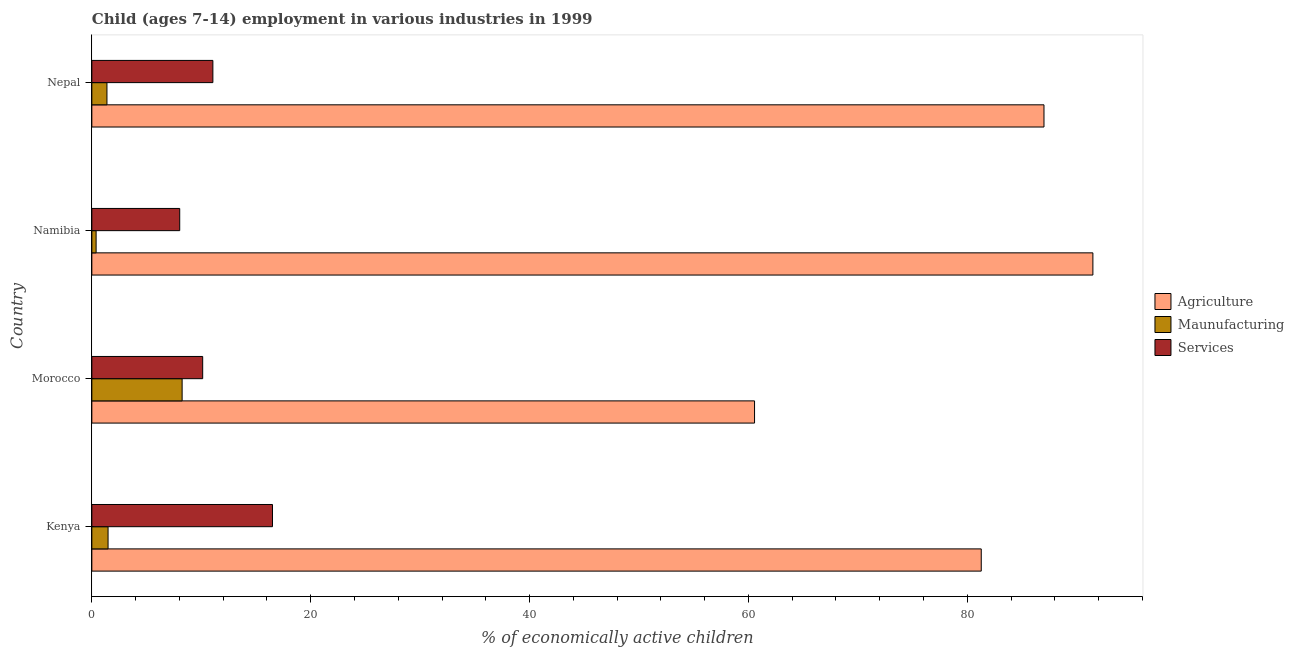How many different coloured bars are there?
Your answer should be compact. 3. How many groups of bars are there?
Ensure brevity in your answer.  4. How many bars are there on the 3rd tick from the bottom?
Offer a very short reply. 3. What is the label of the 1st group of bars from the top?
Provide a succinct answer. Nepal. In how many cases, is the number of bars for a given country not equal to the number of legend labels?
Keep it short and to the point. 0. What is the percentage of economically active children in services in Nepal?
Ensure brevity in your answer.  11.06. Across all countries, what is the maximum percentage of economically active children in services?
Give a very brief answer. 16.51. Across all countries, what is the minimum percentage of economically active children in services?
Ensure brevity in your answer.  8.03. In which country was the percentage of economically active children in agriculture maximum?
Give a very brief answer. Namibia. In which country was the percentage of economically active children in services minimum?
Make the answer very short. Namibia. What is the total percentage of economically active children in agriculture in the graph?
Provide a short and direct response. 320.33. What is the difference between the percentage of economically active children in services in Kenya and that in Nepal?
Provide a succinct answer. 5.45. What is the difference between the percentage of economically active children in services in Kenya and the percentage of economically active children in agriculture in Nepal?
Give a very brief answer. -70.5. What is the average percentage of economically active children in manufacturing per country?
Provide a short and direct response. 2.88. What is the difference between the percentage of economically active children in services and percentage of economically active children in manufacturing in Nepal?
Your answer should be very brief. 9.68. What is the ratio of the percentage of economically active children in services in Morocco to that in Namibia?
Give a very brief answer. 1.26. Is the difference between the percentage of economically active children in agriculture in Namibia and Nepal greater than the difference between the percentage of economically active children in services in Namibia and Nepal?
Ensure brevity in your answer.  Yes. What is the difference between the highest and the second highest percentage of economically active children in services?
Make the answer very short. 5.45. What is the difference between the highest and the lowest percentage of economically active children in agriculture?
Your response must be concise. 30.92. In how many countries, is the percentage of economically active children in services greater than the average percentage of economically active children in services taken over all countries?
Offer a very short reply. 1. Is the sum of the percentage of economically active children in manufacturing in Kenya and Namibia greater than the maximum percentage of economically active children in agriculture across all countries?
Your response must be concise. No. What does the 3rd bar from the top in Namibia represents?
Offer a terse response. Agriculture. What does the 2nd bar from the bottom in Kenya represents?
Offer a terse response. Maunufacturing. Is it the case that in every country, the sum of the percentage of economically active children in agriculture and percentage of economically active children in manufacturing is greater than the percentage of economically active children in services?
Make the answer very short. Yes. How many bars are there?
Offer a terse response. 12. How many countries are there in the graph?
Your answer should be compact. 4. Are the values on the major ticks of X-axis written in scientific E-notation?
Offer a terse response. No. Does the graph contain grids?
Offer a terse response. No. Where does the legend appear in the graph?
Your response must be concise. Center right. What is the title of the graph?
Offer a terse response. Child (ages 7-14) employment in various industries in 1999. Does "Financial account" appear as one of the legend labels in the graph?
Keep it short and to the point. No. What is the label or title of the X-axis?
Keep it short and to the point. % of economically active children. What is the label or title of the Y-axis?
Provide a succinct answer. Country. What is the % of economically active children of Agriculture in Kenya?
Provide a succinct answer. 81.28. What is the % of economically active children in Maunufacturing in Kenya?
Your response must be concise. 1.48. What is the % of economically active children of Services in Kenya?
Give a very brief answer. 16.51. What is the % of economically active children in Agriculture in Morocco?
Provide a short and direct response. 60.56. What is the % of economically active children in Maunufacturing in Morocco?
Offer a terse response. 8.25. What is the % of economically active children in Services in Morocco?
Keep it short and to the point. 10.13. What is the % of economically active children of Agriculture in Namibia?
Give a very brief answer. 91.48. What is the % of economically active children in Maunufacturing in Namibia?
Ensure brevity in your answer.  0.39. What is the % of economically active children in Services in Namibia?
Provide a short and direct response. 8.03. What is the % of economically active children in Agriculture in Nepal?
Provide a succinct answer. 87.01. What is the % of economically active children of Maunufacturing in Nepal?
Your response must be concise. 1.38. What is the % of economically active children of Services in Nepal?
Offer a terse response. 11.06. Across all countries, what is the maximum % of economically active children in Agriculture?
Keep it short and to the point. 91.48. Across all countries, what is the maximum % of economically active children of Maunufacturing?
Ensure brevity in your answer.  8.25. Across all countries, what is the maximum % of economically active children in Services?
Your answer should be compact. 16.51. Across all countries, what is the minimum % of economically active children in Agriculture?
Give a very brief answer. 60.56. Across all countries, what is the minimum % of economically active children in Maunufacturing?
Keep it short and to the point. 0.39. Across all countries, what is the minimum % of economically active children of Services?
Your answer should be compact. 8.03. What is the total % of economically active children of Agriculture in the graph?
Your answer should be very brief. 320.33. What is the total % of economically active children in Maunufacturing in the graph?
Provide a short and direct response. 11.5. What is the total % of economically active children of Services in the graph?
Give a very brief answer. 45.73. What is the difference between the % of economically active children of Agriculture in Kenya and that in Morocco?
Provide a short and direct response. 20.72. What is the difference between the % of economically active children of Maunufacturing in Kenya and that in Morocco?
Your answer should be very brief. -6.77. What is the difference between the % of economically active children in Services in Kenya and that in Morocco?
Give a very brief answer. 6.38. What is the difference between the % of economically active children in Agriculture in Kenya and that in Namibia?
Offer a very short reply. -10.2. What is the difference between the % of economically active children in Maunufacturing in Kenya and that in Namibia?
Offer a very short reply. 1.09. What is the difference between the % of economically active children of Services in Kenya and that in Namibia?
Make the answer very short. 8.48. What is the difference between the % of economically active children in Agriculture in Kenya and that in Nepal?
Your answer should be very brief. -5.73. What is the difference between the % of economically active children in Maunufacturing in Kenya and that in Nepal?
Your answer should be very brief. 0.1. What is the difference between the % of economically active children of Services in Kenya and that in Nepal?
Your response must be concise. 5.45. What is the difference between the % of economically active children in Agriculture in Morocco and that in Namibia?
Offer a terse response. -30.92. What is the difference between the % of economically active children in Maunufacturing in Morocco and that in Namibia?
Offer a terse response. 7.86. What is the difference between the % of economically active children of Services in Morocco and that in Namibia?
Your answer should be compact. 2.1. What is the difference between the % of economically active children in Agriculture in Morocco and that in Nepal?
Offer a terse response. -26.45. What is the difference between the % of economically active children in Maunufacturing in Morocco and that in Nepal?
Ensure brevity in your answer.  6.87. What is the difference between the % of economically active children of Services in Morocco and that in Nepal?
Offer a very short reply. -0.93. What is the difference between the % of economically active children of Agriculture in Namibia and that in Nepal?
Your response must be concise. 4.47. What is the difference between the % of economically active children in Maunufacturing in Namibia and that in Nepal?
Your response must be concise. -0.99. What is the difference between the % of economically active children of Services in Namibia and that in Nepal?
Give a very brief answer. -3.03. What is the difference between the % of economically active children of Agriculture in Kenya and the % of economically active children of Maunufacturing in Morocco?
Your response must be concise. 73.03. What is the difference between the % of economically active children of Agriculture in Kenya and the % of economically active children of Services in Morocco?
Your answer should be very brief. 71.15. What is the difference between the % of economically active children in Maunufacturing in Kenya and the % of economically active children in Services in Morocco?
Offer a terse response. -8.65. What is the difference between the % of economically active children of Agriculture in Kenya and the % of economically active children of Maunufacturing in Namibia?
Give a very brief answer. 80.89. What is the difference between the % of economically active children of Agriculture in Kenya and the % of economically active children of Services in Namibia?
Your answer should be very brief. 73.25. What is the difference between the % of economically active children in Maunufacturing in Kenya and the % of economically active children in Services in Namibia?
Keep it short and to the point. -6.55. What is the difference between the % of economically active children of Agriculture in Kenya and the % of economically active children of Maunufacturing in Nepal?
Make the answer very short. 79.9. What is the difference between the % of economically active children in Agriculture in Kenya and the % of economically active children in Services in Nepal?
Make the answer very short. 70.22. What is the difference between the % of economically active children in Maunufacturing in Kenya and the % of economically active children in Services in Nepal?
Ensure brevity in your answer.  -9.58. What is the difference between the % of economically active children in Agriculture in Morocco and the % of economically active children in Maunufacturing in Namibia?
Offer a very short reply. 60.17. What is the difference between the % of economically active children in Agriculture in Morocco and the % of economically active children in Services in Namibia?
Your response must be concise. 52.53. What is the difference between the % of economically active children of Maunufacturing in Morocco and the % of economically active children of Services in Namibia?
Offer a terse response. 0.22. What is the difference between the % of economically active children in Agriculture in Morocco and the % of economically active children in Maunufacturing in Nepal?
Your response must be concise. 59.18. What is the difference between the % of economically active children in Agriculture in Morocco and the % of economically active children in Services in Nepal?
Offer a very short reply. 49.5. What is the difference between the % of economically active children in Maunufacturing in Morocco and the % of economically active children in Services in Nepal?
Your response must be concise. -2.81. What is the difference between the % of economically active children of Agriculture in Namibia and the % of economically active children of Maunufacturing in Nepal?
Make the answer very short. 90.1. What is the difference between the % of economically active children of Agriculture in Namibia and the % of economically active children of Services in Nepal?
Provide a succinct answer. 80.42. What is the difference between the % of economically active children in Maunufacturing in Namibia and the % of economically active children in Services in Nepal?
Make the answer very short. -10.67. What is the average % of economically active children in Agriculture per country?
Provide a succinct answer. 80.08. What is the average % of economically active children in Maunufacturing per country?
Make the answer very short. 2.88. What is the average % of economically active children in Services per country?
Your answer should be very brief. 11.43. What is the difference between the % of economically active children in Agriculture and % of economically active children in Maunufacturing in Kenya?
Provide a short and direct response. 79.8. What is the difference between the % of economically active children in Agriculture and % of economically active children in Services in Kenya?
Ensure brevity in your answer.  64.77. What is the difference between the % of economically active children of Maunufacturing and % of economically active children of Services in Kenya?
Make the answer very short. -15.03. What is the difference between the % of economically active children of Agriculture and % of economically active children of Maunufacturing in Morocco?
Offer a terse response. 52.31. What is the difference between the % of economically active children in Agriculture and % of economically active children in Services in Morocco?
Give a very brief answer. 50.43. What is the difference between the % of economically active children of Maunufacturing and % of economically active children of Services in Morocco?
Ensure brevity in your answer.  -1.88. What is the difference between the % of economically active children in Agriculture and % of economically active children in Maunufacturing in Namibia?
Your answer should be compact. 91.09. What is the difference between the % of economically active children of Agriculture and % of economically active children of Services in Namibia?
Offer a terse response. 83.45. What is the difference between the % of economically active children of Maunufacturing and % of economically active children of Services in Namibia?
Ensure brevity in your answer.  -7.64. What is the difference between the % of economically active children of Agriculture and % of economically active children of Maunufacturing in Nepal?
Your response must be concise. 85.63. What is the difference between the % of economically active children of Agriculture and % of economically active children of Services in Nepal?
Offer a terse response. 75.95. What is the difference between the % of economically active children of Maunufacturing and % of economically active children of Services in Nepal?
Offer a terse response. -9.68. What is the ratio of the % of economically active children in Agriculture in Kenya to that in Morocco?
Provide a short and direct response. 1.34. What is the ratio of the % of economically active children of Maunufacturing in Kenya to that in Morocco?
Provide a short and direct response. 0.18. What is the ratio of the % of economically active children of Services in Kenya to that in Morocco?
Give a very brief answer. 1.63. What is the ratio of the % of economically active children of Agriculture in Kenya to that in Namibia?
Make the answer very short. 0.89. What is the ratio of the % of economically active children of Maunufacturing in Kenya to that in Namibia?
Ensure brevity in your answer.  3.8. What is the ratio of the % of economically active children in Services in Kenya to that in Namibia?
Offer a terse response. 2.06. What is the ratio of the % of economically active children in Agriculture in Kenya to that in Nepal?
Provide a short and direct response. 0.93. What is the ratio of the % of economically active children of Maunufacturing in Kenya to that in Nepal?
Your response must be concise. 1.07. What is the ratio of the % of economically active children of Services in Kenya to that in Nepal?
Ensure brevity in your answer.  1.49. What is the ratio of the % of economically active children of Agriculture in Morocco to that in Namibia?
Provide a succinct answer. 0.66. What is the ratio of the % of economically active children of Maunufacturing in Morocco to that in Namibia?
Make the answer very short. 21.15. What is the ratio of the % of economically active children of Services in Morocco to that in Namibia?
Make the answer very short. 1.26. What is the ratio of the % of economically active children of Agriculture in Morocco to that in Nepal?
Give a very brief answer. 0.7. What is the ratio of the % of economically active children of Maunufacturing in Morocco to that in Nepal?
Give a very brief answer. 5.98. What is the ratio of the % of economically active children in Services in Morocco to that in Nepal?
Keep it short and to the point. 0.92. What is the ratio of the % of economically active children of Agriculture in Namibia to that in Nepal?
Provide a short and direct response. 1.05. What is the ratio of the % of economically active children in Maunufacturing in Namibia to that in Nepal?
Provide a succinct answer. 0.28. What is the ratio of the % of economically active children of Services in Namibia to that in Nepal?
Provide a short and direct response. 0.73. What is the difference between the highest and the second highest % of economically active children of Agriculture?
Provide a succinct answer. 4.47. What is the difference between the highest and the second highest % of economically active children of Maunufacturing?
Keep it short and to the point. 6.77. What is the difference between the highest and the second highest % of economically active children in Services?
Offer a terse response. 5.45. What is the difference between the highest and the lowest % of economically active children of Agriculture?
Your answer should be very brief. 30.92. What is the difference between the highest and the lowest % of economically active children of Maunufacturing?
Offer a very short reply. 7.86. What is the difference between the highest and the lowest % of economically active children in Services?
Your answer should be compact. 8.48. 